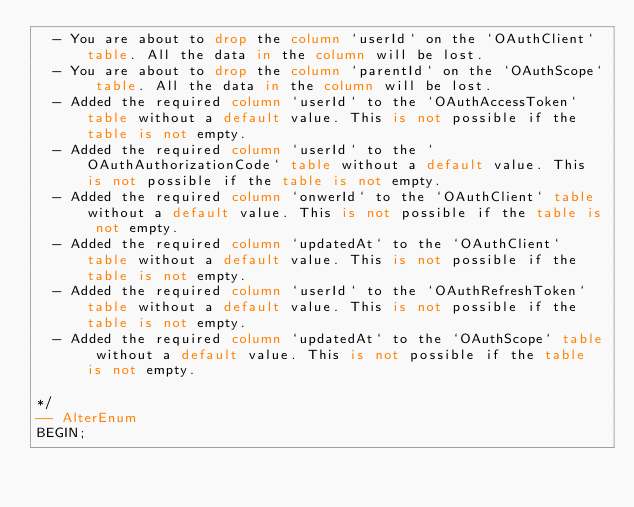<code> <loc_0><loc_0><loc_500><loc_500><_SQL_>  - You are about to drop the column `userId` on the `OAuthClient` table. All the data in the column will be lost.
  - You are about to drop the column `parentId` on the `OAuthScope` table. All the data in the column will be lost.
  - Added the required column `userId` to the `OAuthAccessToken` table without a default value. This is not possible if the table is not empty.
  - Added the required column `userId` to the `OAuthAuthorizationCode` table without a default value. This is not possible if the table is not empty.
  - Added the required column `onwerId` to the `OAuthClient` table without a default value. This is not possible if the table is not empty.
  - Added the required column `updatedAt` to the `OAuthClient` table without a default value. This is not possible if the table is not empty.
  - Added the required column `userId` to the `OAuthRefreshToken` table without a default value. This is not possible if the table is not empty.
  - Added the required column `updatedAt` to the `OAuthScope` table without a default value. This is not possible if the table is not empty.

*/
-- AlterEnum
BEGIN;</code> 